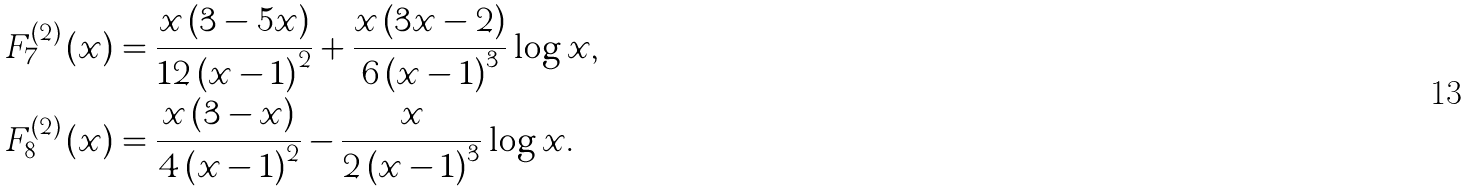Convert formula to latex. <formula><loc_0><loc_0><loc_500><loc_500>F _ { 7 } ^ { ( 2 ) } \left ( x \right ) & = \frac { x \left ( 3 - 5 x \right ) } { 1 2 \left ( x - 1 \right ) ^ { 2 } } + \frac { x \left ( 3 x - 2 \right ) } { 6 \left ( x - 1 \right ) ^ { 3 } } \log x , \\ F _ { 8 } ^ { ( 2 ) } \left ( x \right ) & = \frac { x \left ( 3 - x \right ) } { 4 \left ( x - 1 \right ) ^ { 2 } } - \frac { x } { 2 \left ( x - 1 \right ) ^ { 3 } } \log x .</formula> 